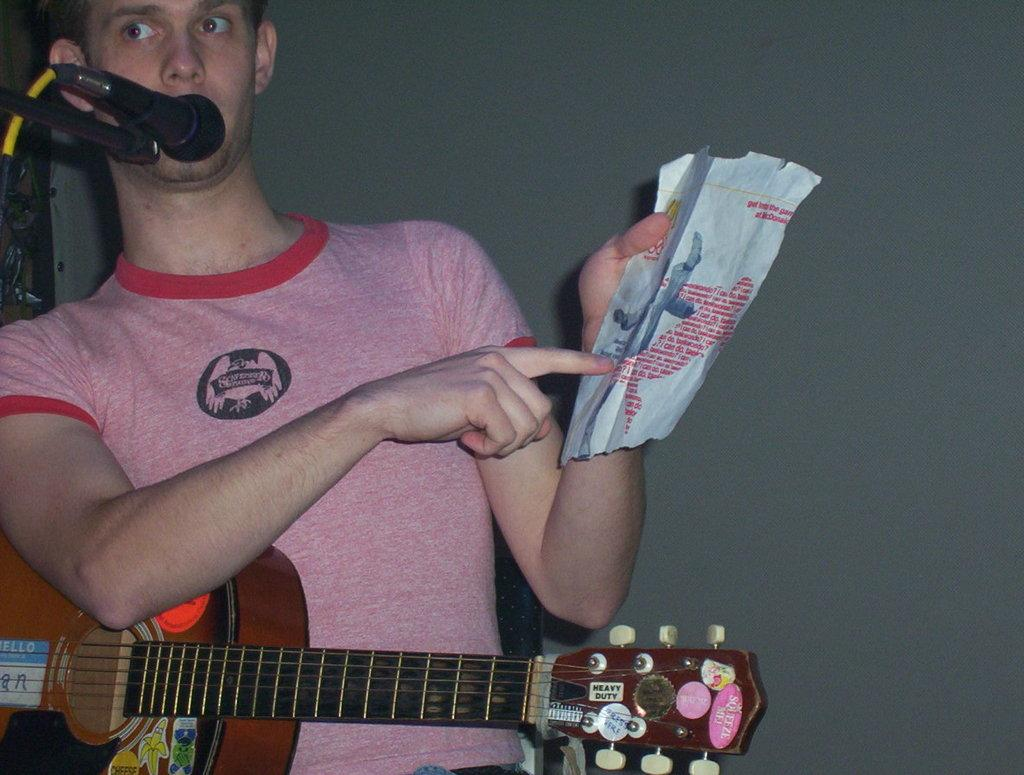What is the man in the image holding? The man is holding a guitar and a paper with his hand. What is the man doing with the microphone? The man is talking on a microphone. What can be seen in the background of the image? There is a wall in the background of the image. What type of battle is depicted on the canvas in the image? There is no canvas or battle present in the image. What color is the clover that the man is holding in the image? There is no clover present in the image. 